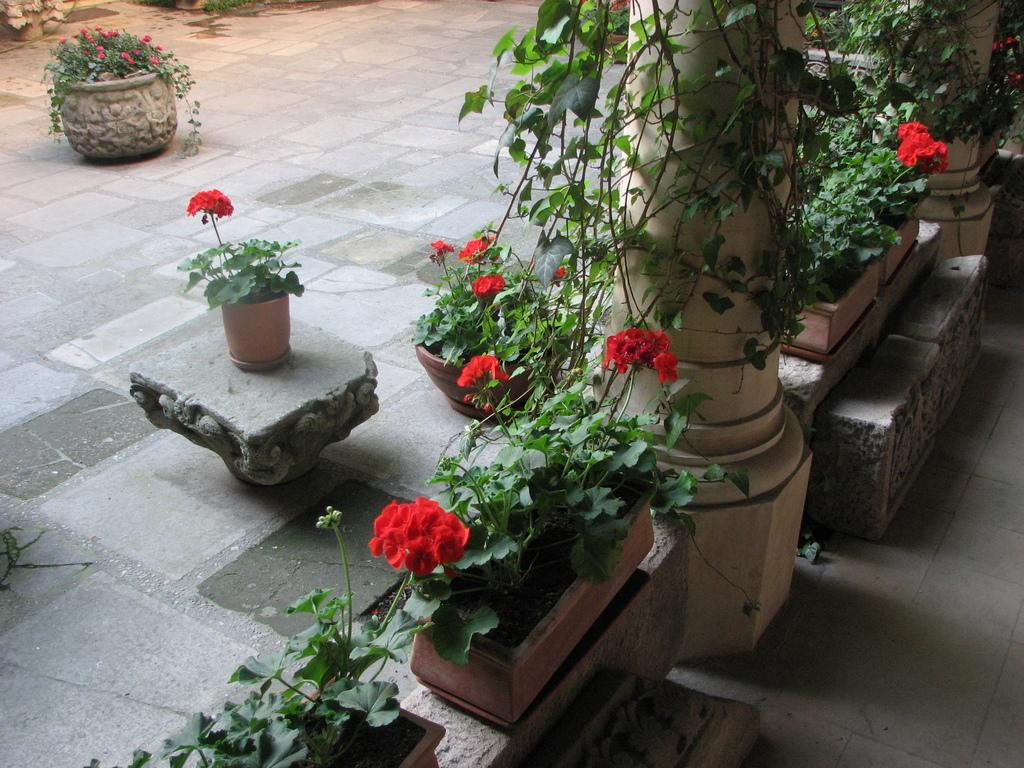What architectural elements can be seen in the image? There are pillars in the image. What type of vegetation is present in the image? Creepers are present in the image. Where are the flower pots located in the image? Flower pots are on platforms in the image. What surface is at the bottom of the image? There is a floor at the bottom of the image. What country is depicted in the image? The image does not depict a country; it features pillars, creepers, flower pots, and a floor. Who is the partner of the person in the image? There is no person present in the image, so it is not possible to determine who their partner might be. 